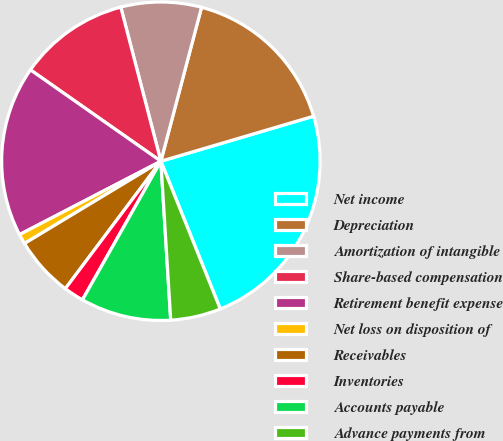Convert chart. <chart><loc_0><loc_0><loc_500><loc_500><pie_chart><fcel>Net income<fcel>Depreciation<fcel>Amortization of intangible<fcel>Share-based compensation<fcel>Retirement benefit expense<fcel>Net loss on disposition of<fcel>Receivables<fcel>Inventories<fcel>Accounts payable<fcel>Advance payments from<nl><fcel>23.47%<fcel>16.32%<fcel>8.16%<fcel>11.22%<fcel>17.34%<fcel>1.02%<fcel>6.12%<fcel>2.04%<fcel>9.18%<fcel>5.1%<nl></chart> 